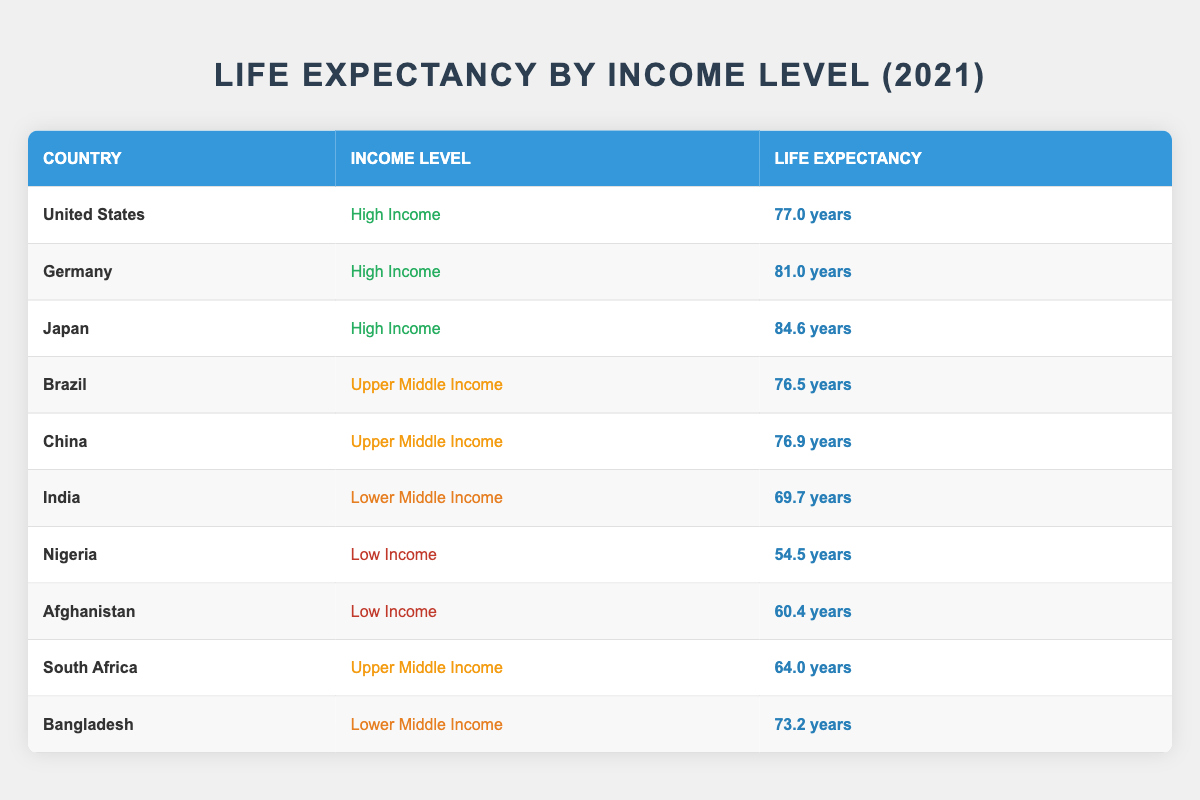What is the life expectancy of Japan? By looking at the table, we see that Japan is listed in the high-income category and its life expectancy is stated as 84.6 years.
Answer: 84.6 years Which country has the lowest life expectancy listed? In the table, the country with the lowest life expectancy is Nigeria, which is categorized as low income with a life expectancy of 54.5 years.
Answer: Nigeria What is the average life expectancy of upper middle-income countries? To calculate the average, we need to find the life expectancy values for upper middle-income countries: Brazil (76.5), China (76.9), and South Africa (64.0). The total is 76.5 + 76.9 + 64.0 = 217.4. To find the average, we divide by the number of countries (3): 217.4 / 3 ≈ 72.47.
Answer: Approximately 72.47 years Is India's life expectancy higher than Afghanistan's? By comparing the life expectancy values from the table, India's life expectancy is 69.7 years while Afghanistan's is 60.4 years. Since 69.7 is greater than 60.4, the statement is true.
Answer: Yes How many countries listed have a life expectancy greater than 80 years? From the table, Japan (84.6) and Germany (81.0) have life expectancies greater than 80 years. There are two such countries in the data.
Answer: 2 Which income level has the highest average life expectancy? To determine which income level has the highest average, we can calculate the average for each income category: High Income has Japan (84.6), Germany (81.0), and the US (77.0), totaling 242.6 for 3 countries gives us 242.6 / 3 = 80.87. Upper Middle Income has Brazil (76.5), China (76.9), and South Africa (64.0) totaling 217.4 for 3 countries gives 217.4 / 3 = 72.47. Lower Middle Income has India (69.7) and Bangladesh (73.2) totaling 142.9 for 2 countries gives 142.9 / 2 = 71.45. Low Income has Nigeria (54.5) and Afghanistan (60.4) totaling 114.9 for 2 countries giving 114.9 / 2 = 57.45. The highest average is 80.87 for High Income.
Answer: High Income What is the difference in life expectancy between China and India? The life expectancy for China is 76.9 years and for India is 69.7 years. To find the difference, we subtract India's life expectancy from China's: 76.9 - 69.7 = 7.2 years.
Answer: 7.2 years Is Germany's life expectancy less than 82 years? From the table, Germany's life expectancy is 81.0 years. Since 81.0 is less than 82, the statement is true.
Answer: Yes 